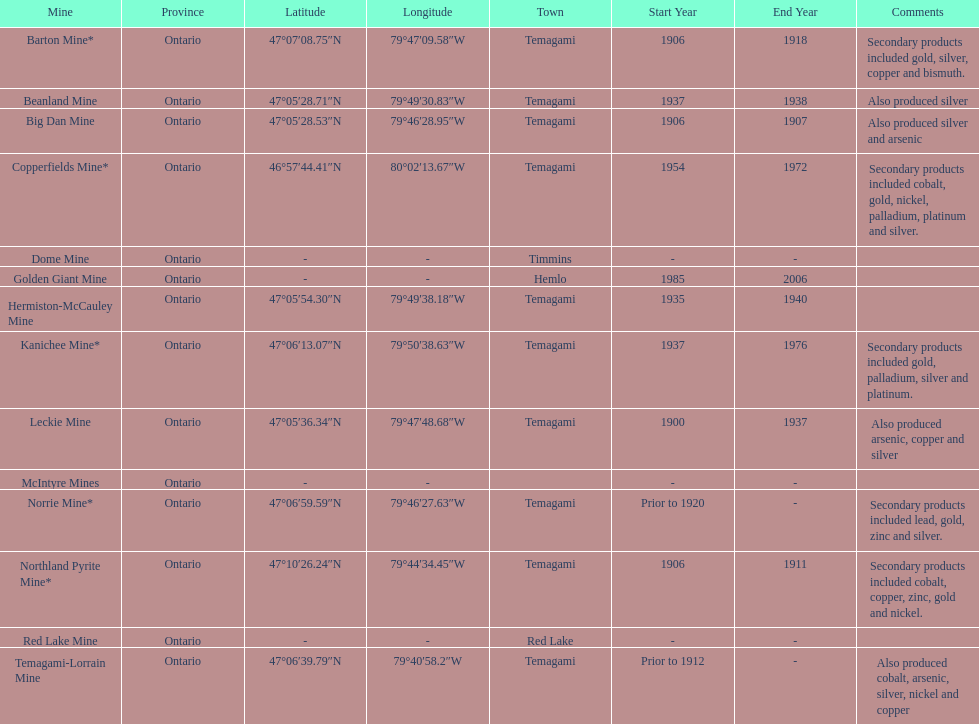What town is listed the most? Temagami. 